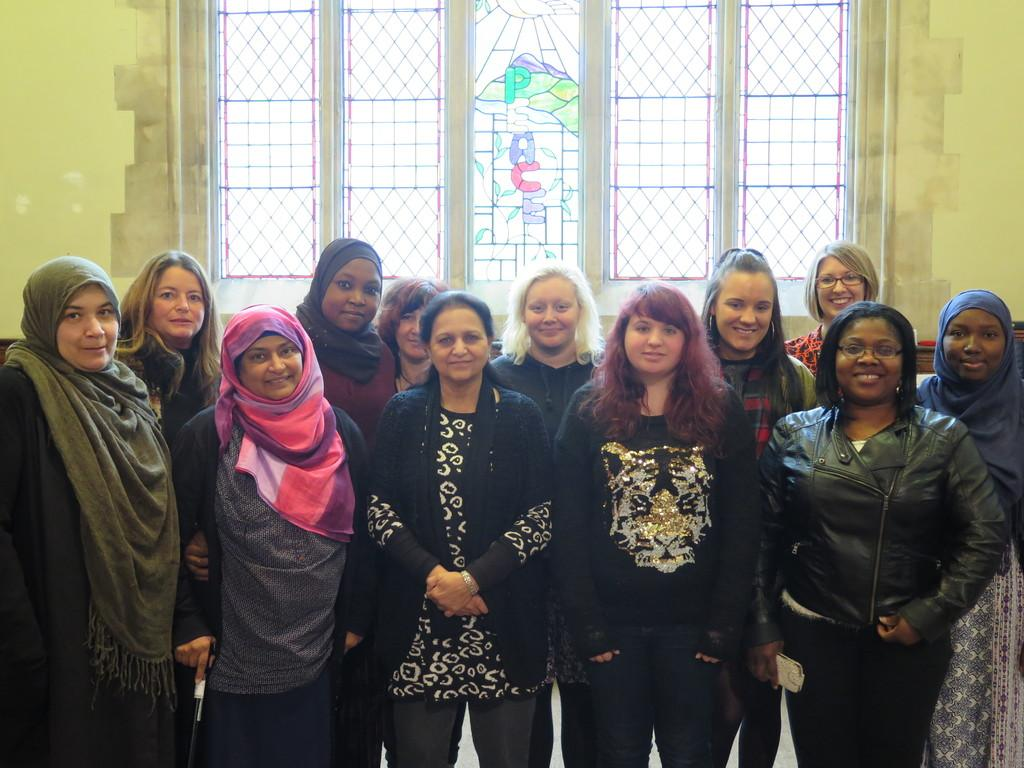How many people are in the image? There is a group of people in the image. Where are the people located in the image? The people are standing on a path. What can be seen in the background of the image? There is a wall in the background of the image. Can you describe the wall in the image? The wall has a window. What type of cart is being used by the people in the image? There is no cart present in the image; the people are standing on a path. What class are the people attending in the image? There is no indication of a class or educational setting in the image. 